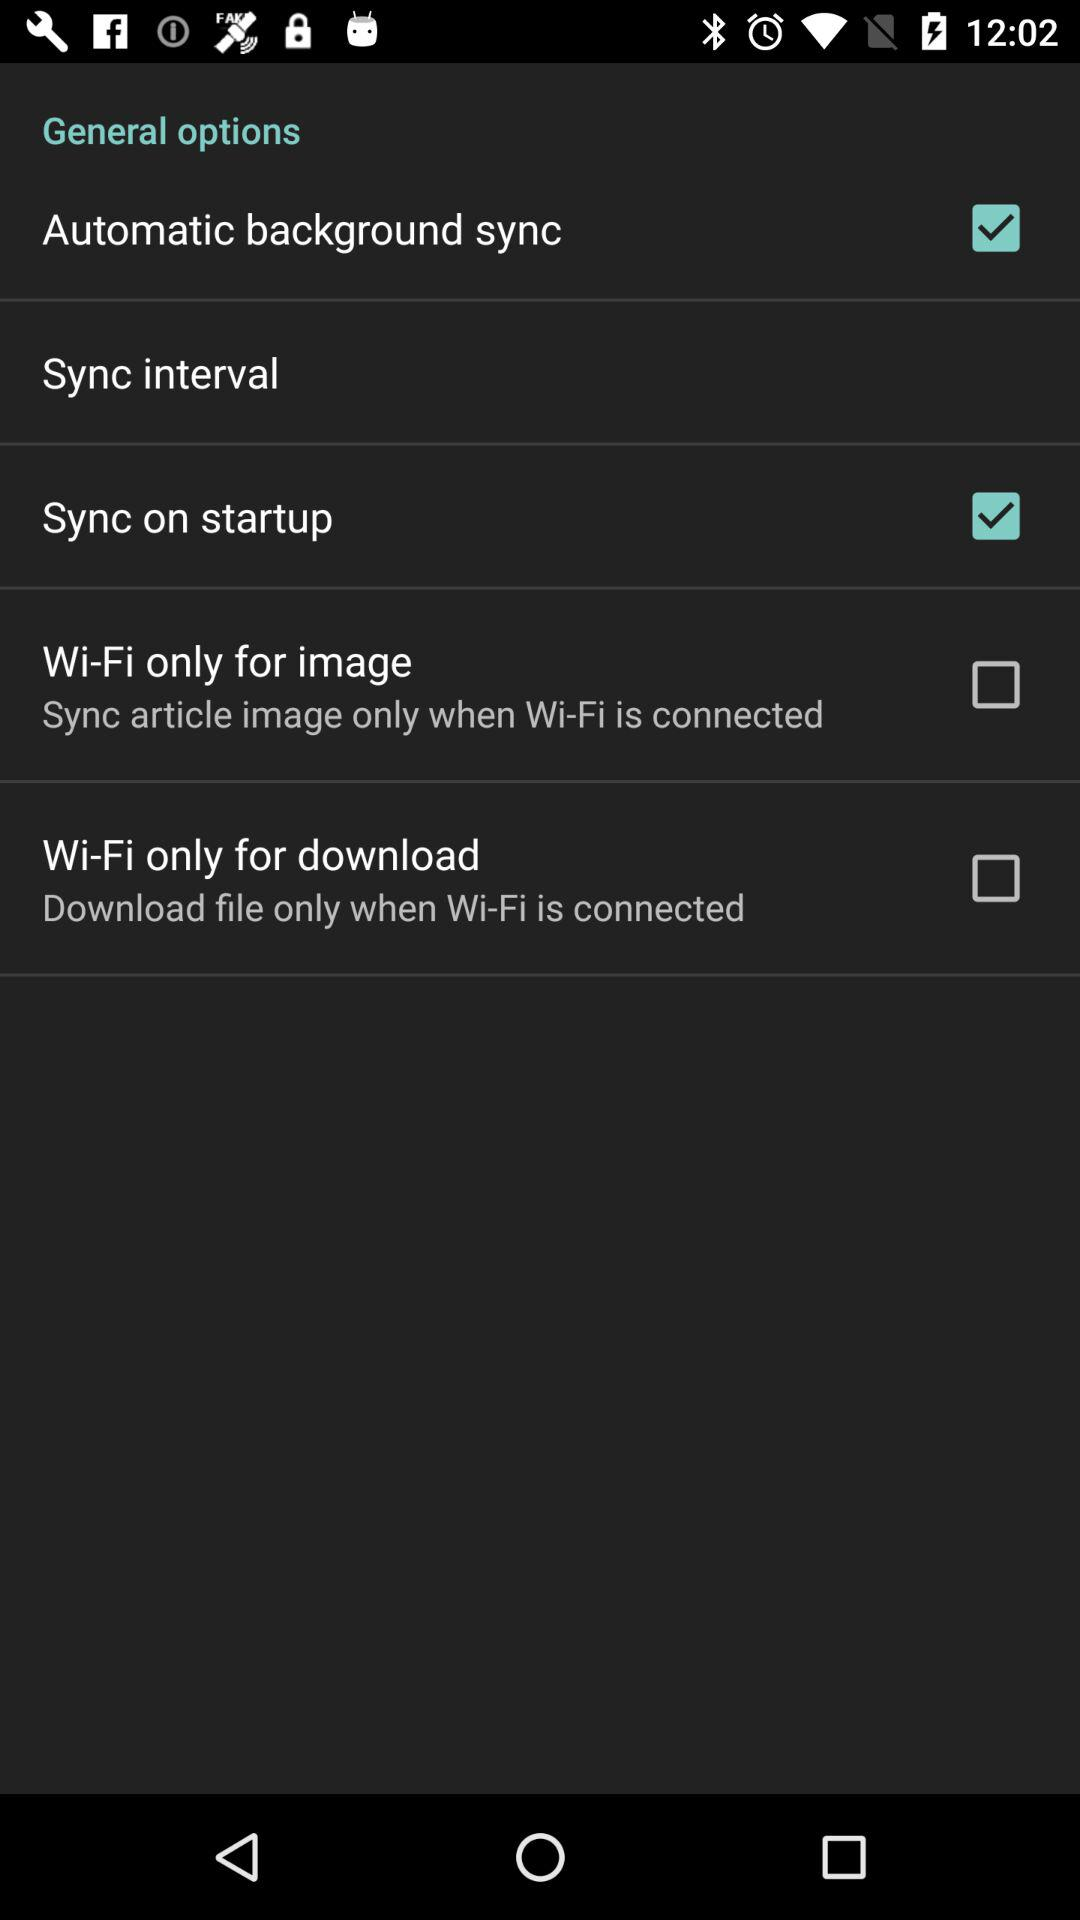How many Wi-Fi only options are there?
Answer the question using a single word or phrase. 2 